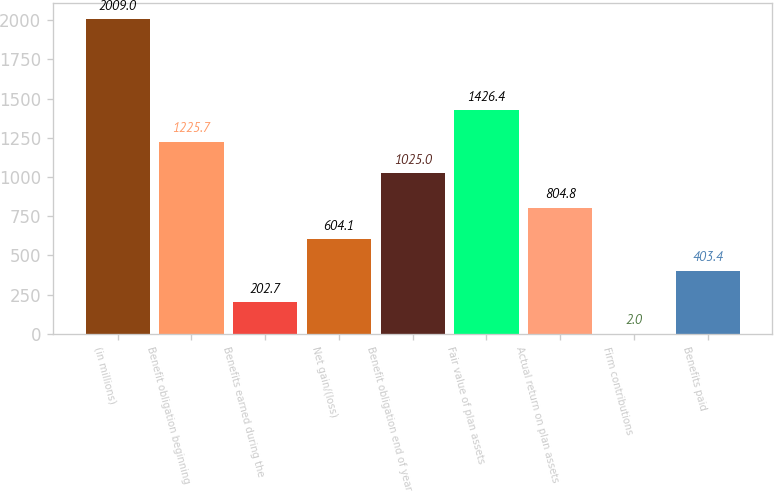Convert chart. <chart><loc_0><loc_0><loc_500><loc_500><bar_chart><fcel>(in millions)<fcel>Benefit obligation beginning<fcel>Benefits earned during the<fcel>Net gain/(loss)<fcel>Benefit obligation end of year<fcel>Fair value of plan assets<fcel>Actual return on plan assets<fcel>Firm contributions<fcel>Benefits paid<nl><fcel>2009<fcel>1225.7<fcel>202.7<fcel>604.1<fcel>1025<fcel>1426.4<fcel>804.8<fcel>2<fcel>403.4<nl></chart> 